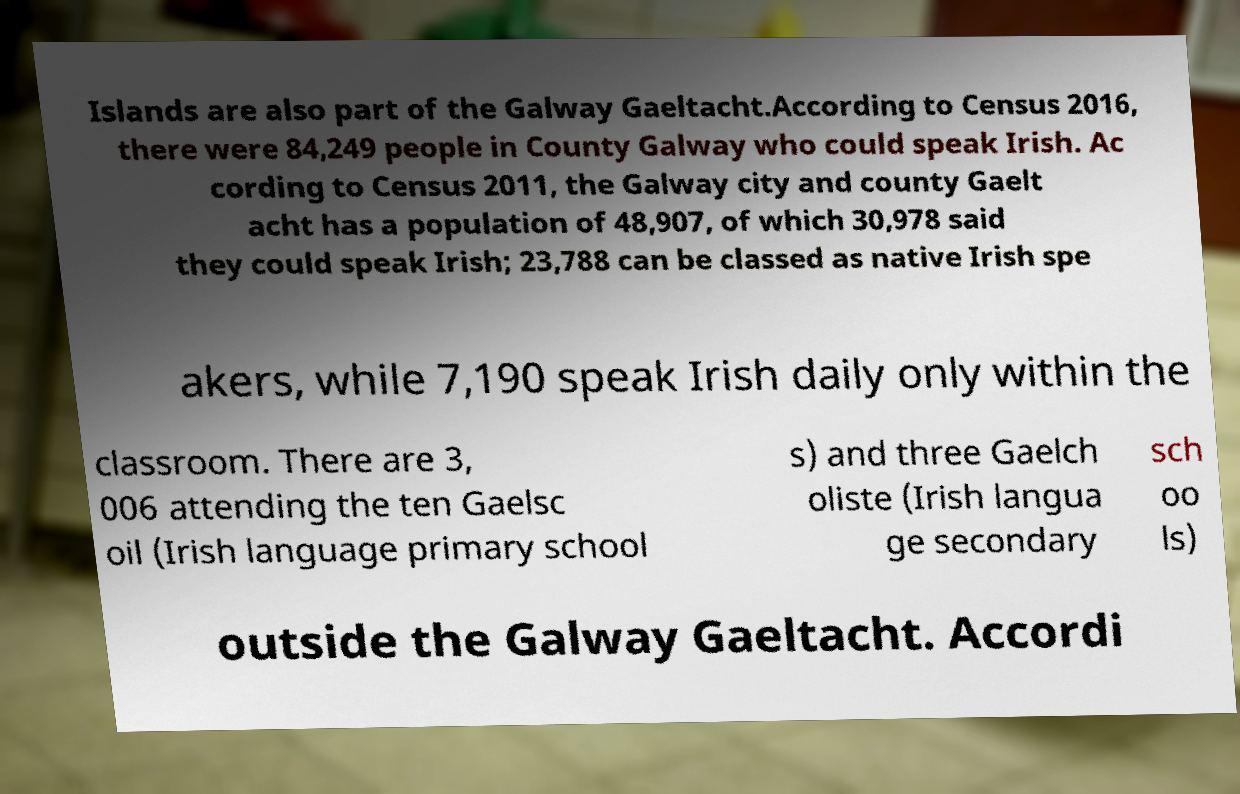Please read and relay the text visible in this image. What does it say? Islands are also part of the Galway Gaeltacht.According to Census 2016, there were 84,249 people in County Galway who could speak Irish. Ac cording to Census 2011, the Galway city and county Gaelt acht has a population of 48,907, of which 30,978 said they could speak Irish; 23,788 can be classed as native Irish spe akers, while 7,190 speak Irish daily only within the classroom. There are 3, 006 attending the ten Gaelsc oil (Irish language primary school s) and three Gaelch oliste (Irish langua ge secondary sch oo ls) outside the Galway Gaeltacht. Accordi 